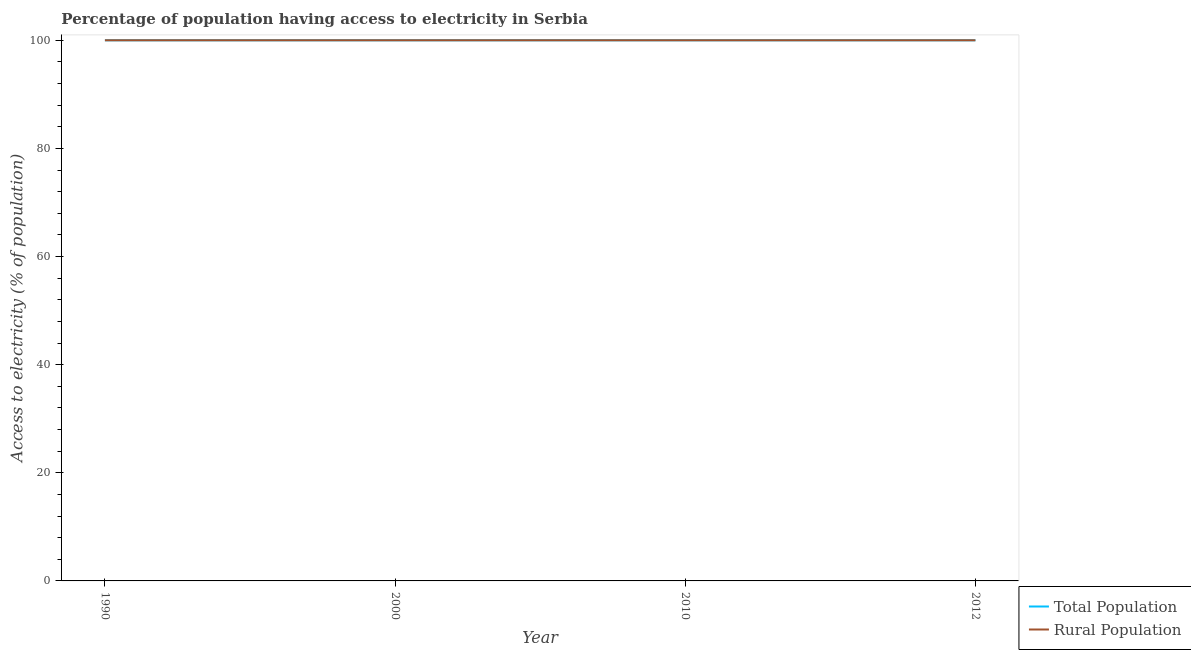How many different coloured lines are there?
Ensure brevity in your answer.  2. Is the number of lines equal to the number of legend labels?
Your answer should be compact. Yes. What is the percentage of rural population having access to electricity in 2012?
Provide a short and direct response. 100. Across all years, what is the maximum percentage of rural population having access to electricity?
Your answer should be compact. 100. Across all years, what is the minimum percentage of rural population having access to electricity?
Ensure brevity in your answer.  100. In which year was the percentage of population having access to electricity maximum?
Make the answer very short. 1990. What is the total percentage of rural population having access to electricity in the graph?
Make the answer very short. 400. What is the difference between the percentage of rural population having access to electricity in 2010 and that in 2012?
Your answer should be compact. 0. What is the difference between the percentage of rural population having access to electricity in 2010 and the percentage of population having access to electricity in 2012?
Give a very brief answer. 0. What is the average percentage of rural population having access to electricity per year?
Your answer should be very brief. 100. In how many years, is the percentage of rural population having access to electricity greater than 52 %?
Ensure brevity in your answer.  4. What is the difference between the highest and the lowest percentage of rural population having access to electricity?
Give a very brief answer. 0. In how many years, is the percentage of population having access to electricity greater than the average percentage of population having access to electricity taken over all years?
Your answer should be compact. 0. Is the percentage of rural population having access to electricity strictly greater than the percentage of population having access to electricity over the years?
Your response must be concise. No. How many years are there in the graph?
Offer a very short reply. 4. What is the difference between two consecutive major ticks on the Y-axis?
Give a very brief answer. 20. Are the values on the major ticks of Y-axis written in scientific E-notation?
Keep it short and to the point. No. Does the graph contain any zero values?
Offer a very short reply. No. How many legend labels are there?
Your response must be concise. 2. How are the legend labels stacked?
Offer a terse response. Vertical. What is the title of the graph?
Your answer should be very brief. Percentage of population having access to electricity in Serbia. Does "Death rate" appear as one of the legend labels in the graph?
Provide a succinct answer. No. What is the label or title of the X-axis?
Give a very brief answer. Year. What is the label or title of the Y-axis?
Provide a succinct answer. Access to electricity (% of population). What is the Access to electricity (% of population) of Total Population in 1990?
Your response must be concise. 100. What is the Access to electricity (% of population) in Rural Population in 2000?
Provide a short and direct response. 100. What is the Access to electricity (% of population) of Total Population in 2010?
Give a very brief answer. 100. What is the Access to electricity (% of population) of Rural Population in 2010?
Provide a succinct answer. 100. Across all years, what is the maximum Access to electricity (% of population) of Rural Population?
Your answer should be very brief. 100. Across all years, what is the minimum Access to electricity (% of population) in Total Population?
Your answer should be very brief. 100. Across all years, what is the minimum Access to electricity (% of population) of Rural Population?
Make the answer very short. 100. What is the total Access to electricity (% of population) in Total Population in the graph?
Your answer should be compact. 400. What is the total Access to electricity (% of population) of Rural Population in the graph?
Provide a short and direct response. 400. What is the difference between the Access to electricity (% of population) of Rural Population in 1990 and that in 2010?
Your answer should be compact. 0. What is the difference between the Access to electricity (% of population) in Total Population in 1990 and that in 2012?
Provide a succinct answer. 0. What is the difference between the Access to electricity (% of population) of Total Population in 2000 and that in 2010?
Your response must be concise. 0. What is the difference between the Access to electricity (% of population) in Rural Population in 2000 and that in 2010?
Ensure brevity in your answer.  0. What is the difference between the Access to electricity (% of population) in Total Population in 2000 and that in 2012?
Keep it short and to the point. 0. What is the difference between the Access to electricity (% of population) of Rural Population in 2000 and that in 2012?
Give a very brief answer. 0. What is the difference between the Access to electricity (% of population) of Rural Population in 2010 and that in 2012?
Your answer should be compact. 0. What is the difference between the Access to electricity (% of population) of Total Population in 1990 and the Access to electricity (% of population) of Rural Population in 2000?
Your answer should be compact. 0. What is the difference between the Access to electricity (% of population) of Total Population in 1990 and the Access to electricity (% of population) of Rural Population in 2012?
Keep it short and to the point. 0. What is the difference between the Access to electricity (% of population) in Total Population in 2000 and the Access to electricity (% of population) in Rural Population in 2010?
Keep it short and to the point. 0. What is the difference between the Access to electricity (% of population) in Total Population in 2010 and the Access to electricity (% of population) in Rural Population in 2012?
Ensure brevity in your answer.  0. What is the average Access to electricity (% of population) in Total Population per year?
Your answer should be very brief. 100. In the year 1990, what is the difference between the Access to electricity (% of population) in Total Population and Access to electricity (% of population) in Rural Population?
Ensure brevity in your answer.  0. In the year 2000, what is the difference between the Access to electricity (% of population) of Total Population and Access to electricity (% of population) of Rural Population?
Your answer should be very brief. 0. In the year 2012, what is the difference between the Access to electricity (% of population) of Total Population and Access to electricity (% of population) of Rural Population?
Make the answer very short. 0. What is the ratio of the Access to electricity (% of population) of Rural Population in 1990 to that in 2000?
Ensure brevity in your answer.  1. What is the ratio of the Access to electricity (% of population) in Total Population in 1990 to that in 2010?
Make the answer very short. 1. What is the ratio of the Access to electricity (% of population) of Rural Population in 1990 to that in 2010?
Make the answer very short. 1. What is the ratio of the Access to electricity (% of population) of Total Population in 1990 to that in 2012?
Provide a succinct answer. 1. What is the ratio of the Access to electricity (% of population) of Total Population in 2000 to that in 2010?
Provide a succinct answer. 1. What is the ratio of the Access to electricity (% of population) of Total Population in 2000 to that in 2012?
Your answer should be very brief. 1. What is the ratio of the Access to electricity (% of population) of Rural Population in 2000 to that in 2012?
Provide a short and direct response. 1. What is the difference between the highest and the lowest Access to electricity (% of population) in Total Population?
Your answer should be very brief. 0. What is the difference between the highest and the lowest Access to electricity (% of population) of Rural Population?
Keep it short and to the point. 0. 